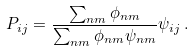<formula> <loc_0><loc_0><loc_500><loc_500>P _ { i j } = \frac { \sum _ { n m } \phi _ { n m } } { \sum _ { n m } \phi _ { n m } \psi _ { n m } } \psi _ { i j } \, .</formula> 